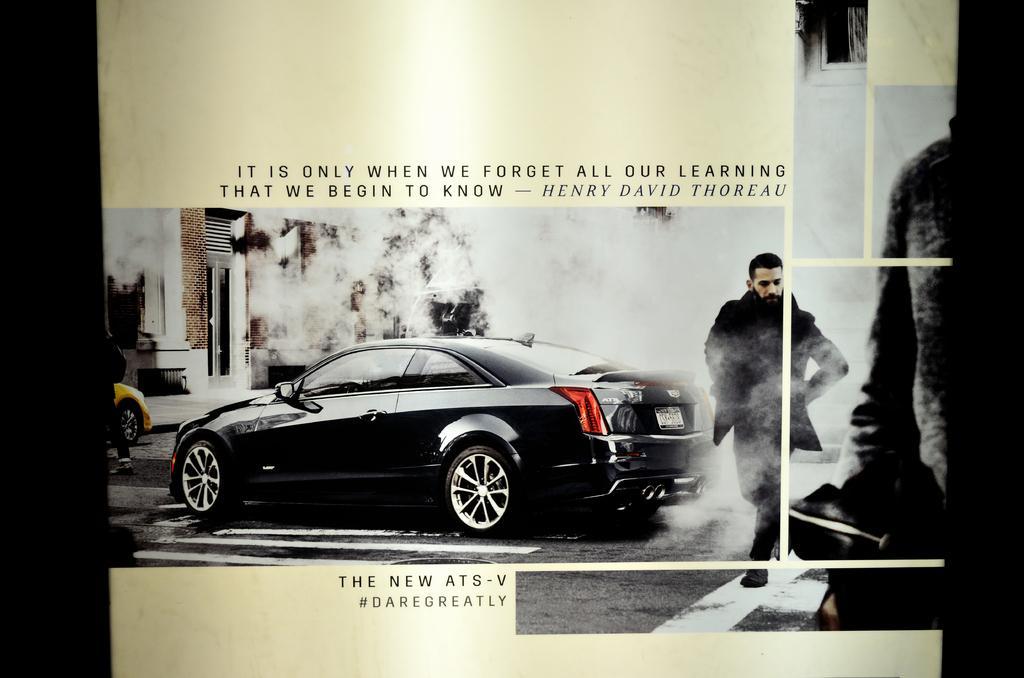In one or two sentences, can you explain what this image depicts? It is an edited image. In this image there are cars on the road. On the right side of the image there are two people. In the background of the image there is a building and there is some text written on the image. 